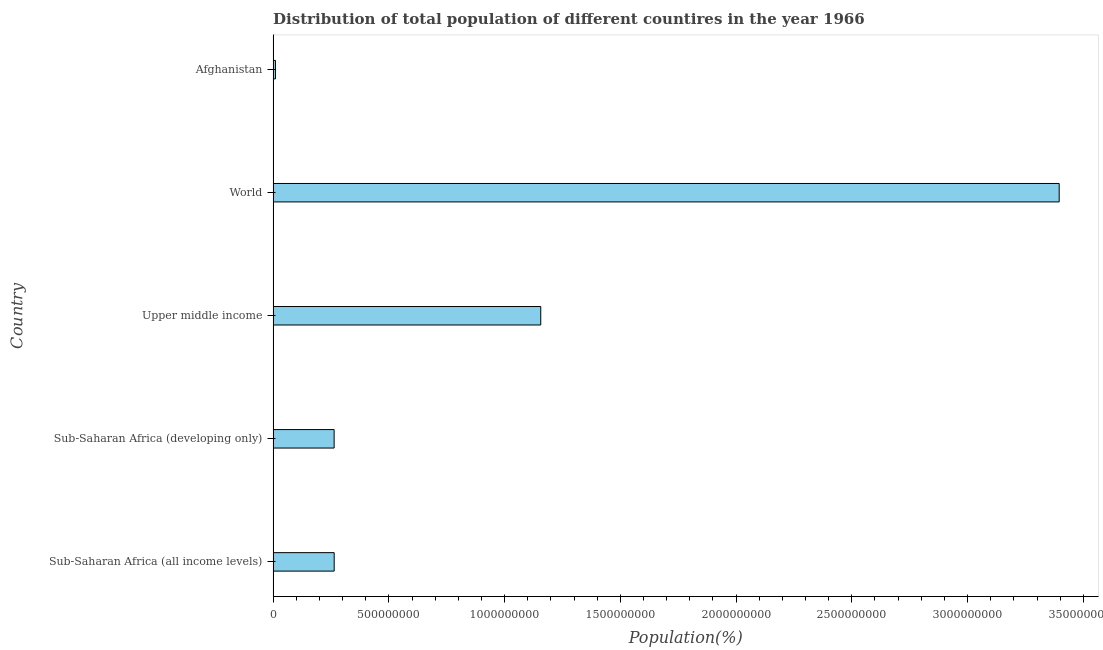Does the graph contain any zero values?
Your answer should be compact. No. Does the graph contain grids?
Make the answer very short. No. What is the title of the graph?
Offer a terse response. Distribution of total population of different countires in the year 1966. What is the label or title of the X-axis?
Provide a succinct answer. Population(%). What is the label or title of the Y-axis?
Offer a terse response. Country. What is the population in Afghanistan?
Your answer should be very brief. 1.01e+07. Across all countries, what is the maximum population?
Make the answer very short. 3.40e+09. Across all countries, what is the minimum population?
Provide a short and direct response. 1.01e+07. In which country was the population minimum?
Your answer should be very brief. Afghanistan. What is the sum of the population?
Your response must be concise. 5.09e+09. What is the difference between the population in Sub-Saharan Africa (all income levels) and World?
Offer a very short reply. -3.13e+09. What is the average population per country?
Keep it short and to the point. 1.02e+09. What is the median population?
Keep it short and to the point. 2.64e+08. What is the ratio of the population in Sub-Saharan Africa (all income levels) to that in Upper middle income?
Provide a succinct answer. 0.23. Is the population in Afghanistan less than that in Sub-Saharan Africa (developing only)?
Offer a very short reply. Yes. Is the difference between the population in Afghanistan and Upper middle income greater than the difference between any two countries?
Give a very brief answer. No. What is the difference between the highest and the second highest population?
Provide a short and direct response. 2.24e+09. What is the difference between the highest and the lowest population?
Offer a terse response. 3.39e+09. How many bars are there?
Make the answer very short. 5. How many countries are there in the graph?
Offer a terse response. 5. What is the difference between two consecutive major ticks on the X-axis?
Provide a succinct answer. 5.00e+08. What is the Population(%) of Sub-Saharan Africa (all income levels)?
Ensure brevity in your answer.  2.64e+08. What is the Population(%) of Sub-Saharan Africa (developing only)?
Offer a very short reply. 2.64e+08. What is the Population(%) of Upper middle income?
Keep it short and to the point. 1.16e+09. What is the Population(%) of World?
Offer a very short reply. 3.40e+09. What is the Population(%) in Afghanistan?
Offer a very short reply. 1.01e+07. What is the difference between the Population(%) in Sub-Saharan Africa (all income levels) and Sub-Saharan Africa (developing only)?
Your answer should be compact. 3.24e+05. What is the difference between the Population(%) in Sub-Saharan Africa (all income levels) and Upper middle income?
Offer a terse response. -8.92e+08. What is the difference between the Population(%) in Sub-Saharan Africa (all income levels) and World?
Ensure brevity in your answer.  -3.13e+09. What is the difference between the Population(%) in Sub-Saharan Africa (all income levels) and Afghanistan?
Provide a short and direct response. 2.54e+08. What is the difference between the Population(%) in Sub-Saharan Africa (developing only) and Upper middle income?
Offer a terse response. -8.93e+08. What is the difference between the Population(%) in Sub-Saharan Africa (developing only) and World?
Make the answer very short. -3.13e+09. What is the difference between the Population(%) in Sub-Saharan Africa (developing only) and Afghanistan?
Give a very brief answer. 2.53e+08. What is the difference between the Population(%) in Upper middle income and World?
Offer a terse response. -2.24e+09. What is the difference between the Population(%) in Upper middle income and Afghanistan?
Provide a succinct answer. 1.15e+09. What is the difference between the Population(%) in World and Afghanistan?
Offer a terse response. 3.39e+09. What is the ratio of the Population(%) in Sub-Saharan Africa (all income levels) to that in Upper middle income?
Keep it short and to the point. 0.23. What is the ratio of the Population(%) in Sub-Saharan Africa (all income levels) to that in World?
Your response must be concise. 0.08. What is the ratio of the Population(%) in Sub-Saharan Africa (all income levels) to that in Afghanistan?
Your answer should be very brief. 26. What is the ratio of the Population(%) in Sub-Saharan Africa (developing only) to that in Upper middle income?
Make the answer very short. 0.23. What is the ratio of the Population(%) in Sub-Saharan Africa (developing only) to that in World?
Your answer should be compact. 0.08. What is the ratio of the Population(%) in Sub-Saharan Africa (developing only) to that in Afghanistan?
Your answer should be very brief. 25.96. What is the ratio of the Population(%) in Upper middle income to that in World?
Offer a terse response. 0.34. What is the ratio of the Population(%) in Upper middle income to that in Afghanistan?
Your answer should be compact. 113.92. What is the ratio of the Population(%) in World to that in Afghanistan?
Your response must be concise. 334.6. 